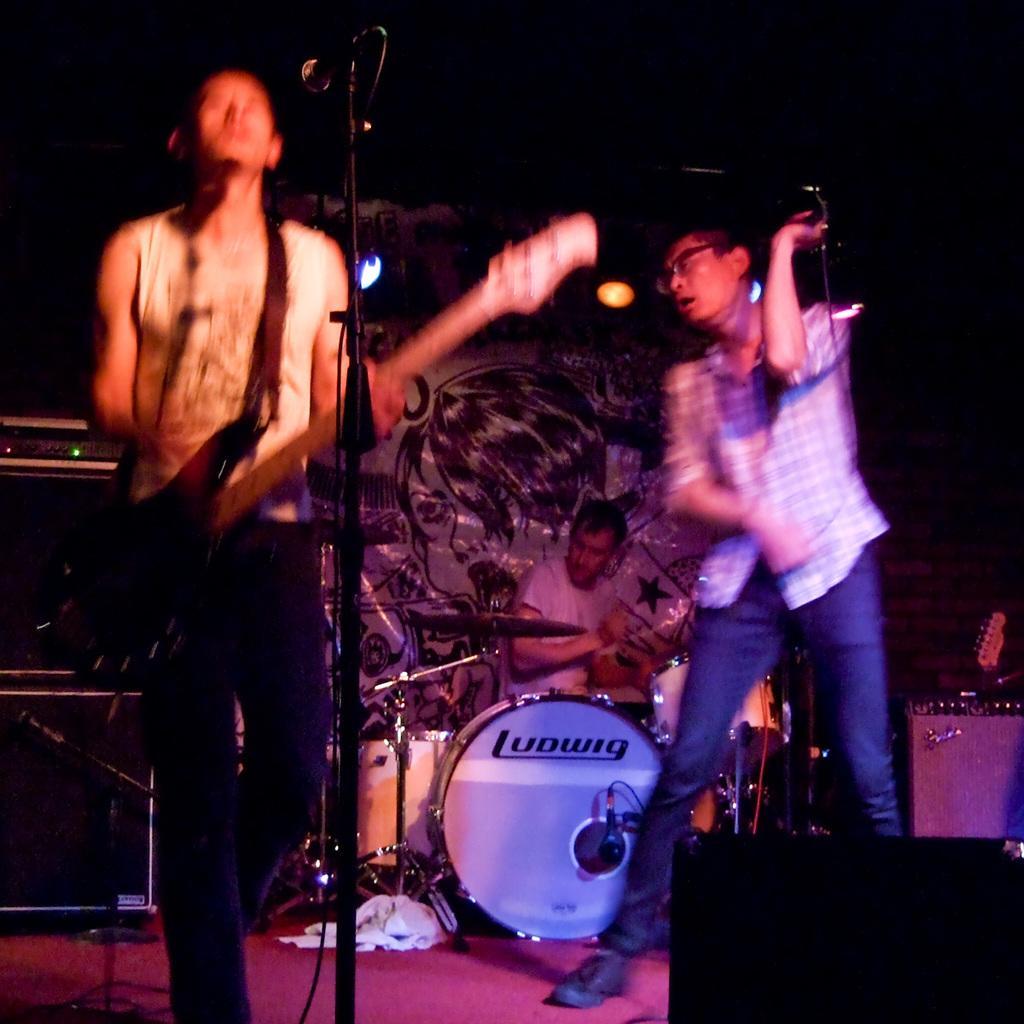In one or two sentences, can you explain what this image depicts? Bottom left side of the image a man is standing and playing guitar. In front of him there is a microphone. Bottom right side of the image a man is standing and holding a microphone. Behind him a person is sitting and playing drums. In the middle of the image there is a banner. Bottom left side of the image there are some electronic devices. 